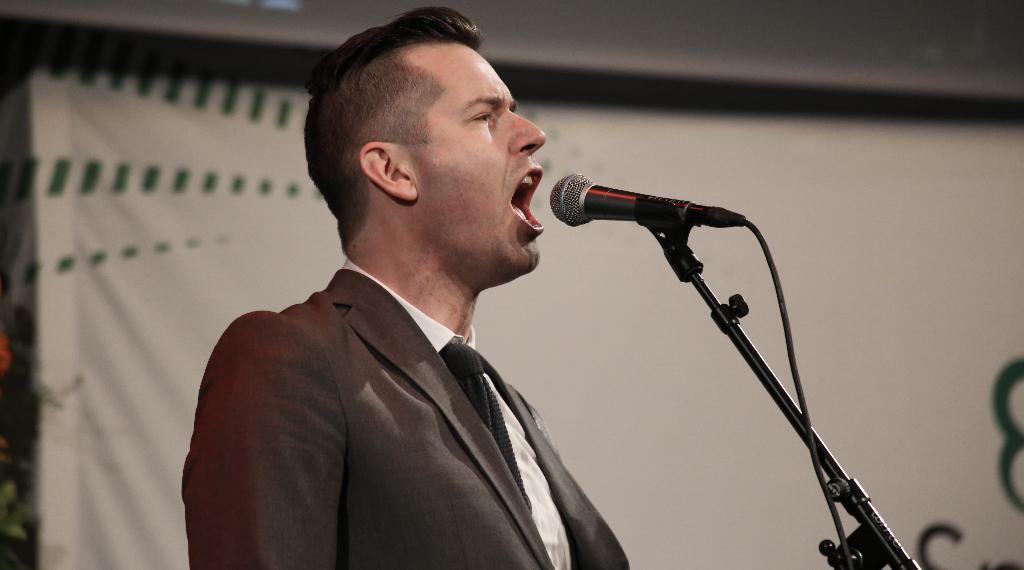How would you summarize this image in a sentence or two? In the front of the image I can see a person. In-front of the person there is a mic along with a mic holder. In the background of the image there is a banner.   